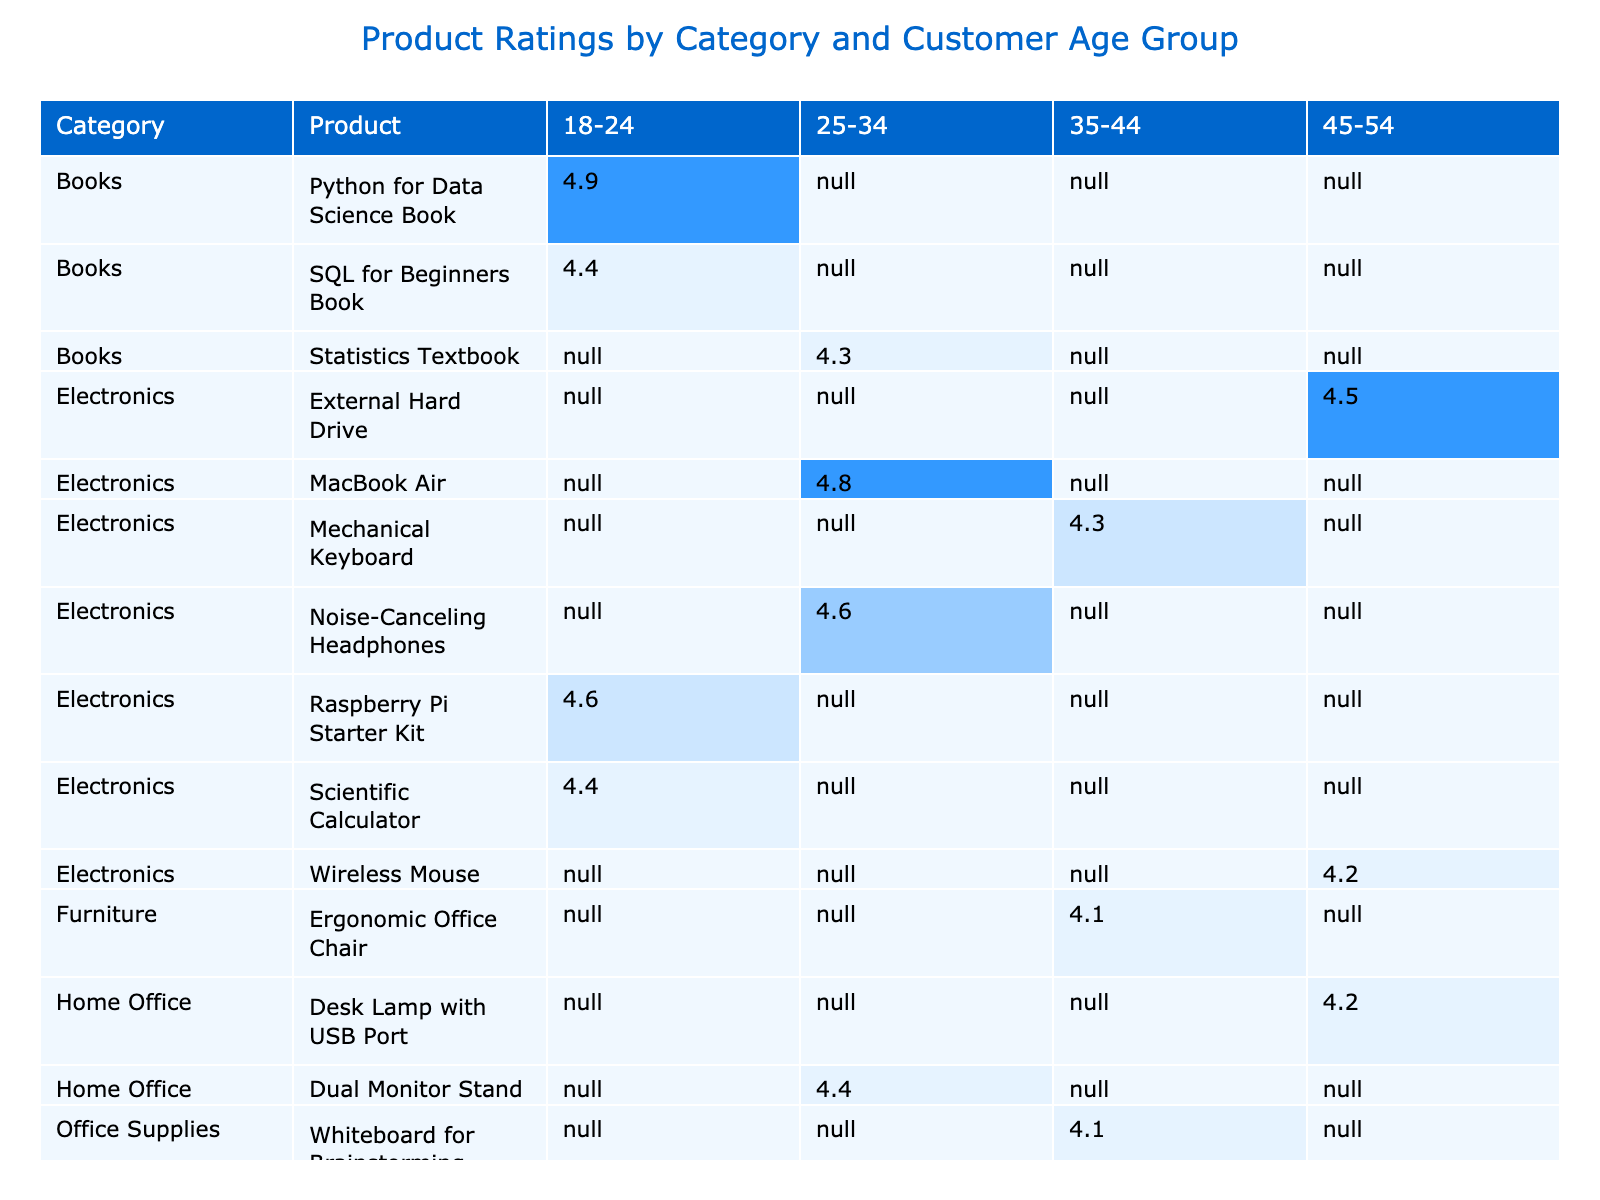What's the highest rating for "Electronics"? In the table, the ratings for products under the category "Electronics" are 4.8 (MacBook Air), 4.2 (Wireless Mouse), 4.4 (Scientific Calculator), 4.6 (Raspberry Pi Starter Kit), 4.5 (External Hard Drive), and 4.6 (Noise-Canceling Headphones). The highest rating among these is 4.8, which is for the MacBook Air.
Answer: 4.8 Which product received the lowest rating in the "Books" category? In the "Books" category, the ratings are 4.9 (Python for Data Science Book), 4.3 (Statistics Textbook), and 4.4 (SQL for Beginners Book). The lowest rating here is 4.3, which belongs to the Statistics Textbook.
Answer: 4.3 Are there any products in the "Toys" category with a rating above 4.5? The only product listed in the "Toys" category is the Lego Technic Set, which has a rating of 4.5. Since it's not above 4.5, the answer is no.
Answer: No What is the average rating for products in the "Online Courses" category? The ratings for products in the "Online Courses" category are 4.8 (Machine Learning Course), 4.7 (Data Analytics Certification), and 4.9 (Data Science Bootcamp). To find the average, we sum these ratings (4.8 + 4.7 + 4.9 = 14.4) and divide by the number of products (3). Thus, the average rating is 14.4 / 3 = 4.8.
Answer: 4.8 Which customer age group gave the highest average rating for the "Furniture" category? In the "Furniture" category, the Ergonomic Office Chair received a rating of 4.1 from the 35-44 age group. There are no other products listed in this category, so that is the only average to consider. Therefore, the highest average for the age group who reviewed this product is 4.1, coming from the 35-44 age group.
Answer: 35-44 